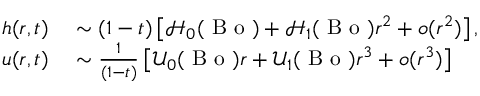Convert formula to latex. <formula><loc_0><loc_0><loc_500><loc_500>\begin{array} { r l } { h ( r , t ) } & \sim ( 1 - t ) \left [ \mathcal { H } _ { 0 } ( B o ) + \mathcal { H } _ { 1 } ( B o ) r ^ { 2 } + o ( r ^ { 2 } ) \right ] , } \\ { u ( r , t ) } & \sim \frac { 1 } { ( 1 - t ) } \left [ \mathcal { U } _ { 0 } ( B o ) r + \mathcal { U } _ { 1 } ( B o ) r ^ { 3 } + o ( r ^ { 3 } ) \right ] } \end{array}</formula> 